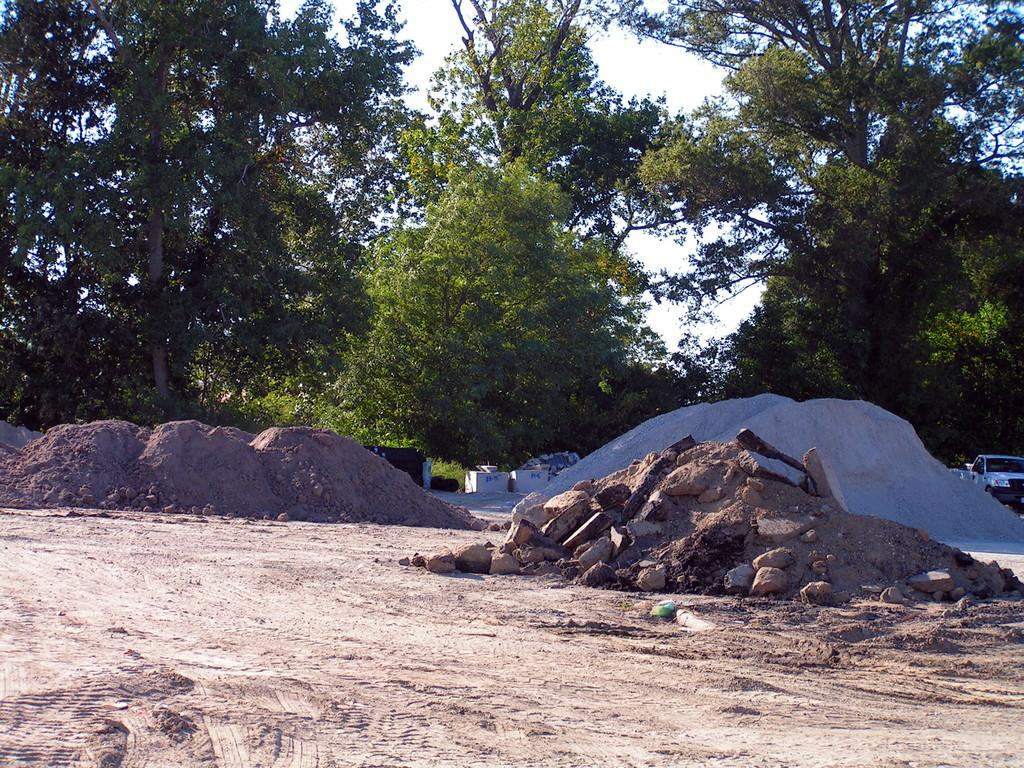What type of natural elements can be seen in the image? There are stones and mud in the image. What man-made object is present in the image? There is a vehicle in the image. What can be seen in the background of the image? Trees and the sky are visible in the background of the image. What type of loaf is being used to kiss the vehicle in the image? There is no loaf or kissing activity present in the image. How many pails can be seen in the image? There are no pails visible in the image. 